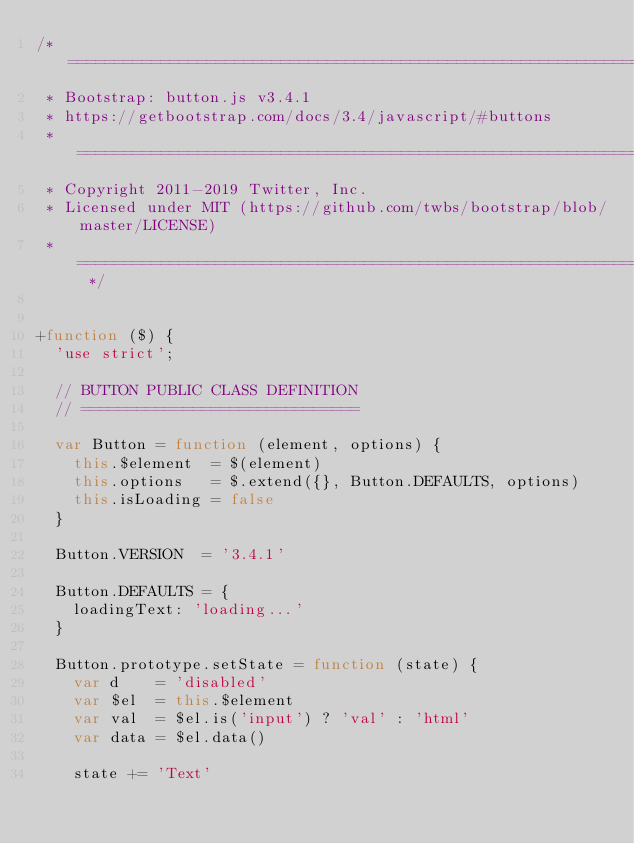<code> <loc_0><loc_0><loc_500><loc_500><_JavaScript_>/* ========================================================================
 * Bootstrap: button.js v3.4.1
 * https://getbootstrap.com/docs/3.4/javascript/#buttons
 * ========================================================================
 * Copyright 2011-2019 Twitter, Inc.
 * Licensed under MIT (https://github.com/twbs/bootstrap/blob/master/LICENSE)
 * ======================================================================== */


+function ($) {
  'use strict';

  // BUTTON PUBLIC CLASS DEFINITION
  // ==============================

  var Button = function (element, options) {
    this.$element  = $(element)
    this.options   = $.extend({}, Button.DEFAULTS, options)
    this.isLoading = false
  }

  Button.VERSION  = '3.4.1'

  Button.DEFAULTS = {
    loadingText: 'loading...'
  }

  Button.prototype.setState = function (state) {
    var d    = 'disabled'
    var $el  = this.$element
    var val  = $el.is('input') ? 'val' : 'html'
    var data = $el.data()

    state += 'Text'
</code> 